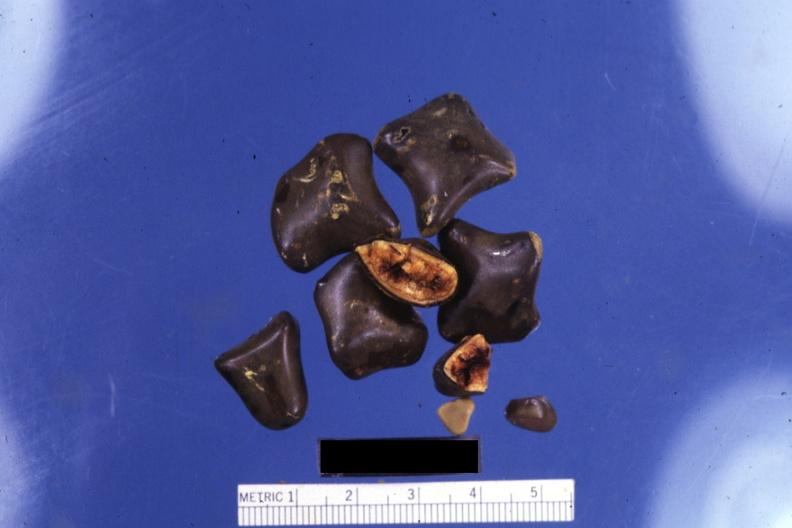does this image show close-up of faceted mixed stones with two showing cut surfaces?
Answer the question using a single word or phrase. Yes 